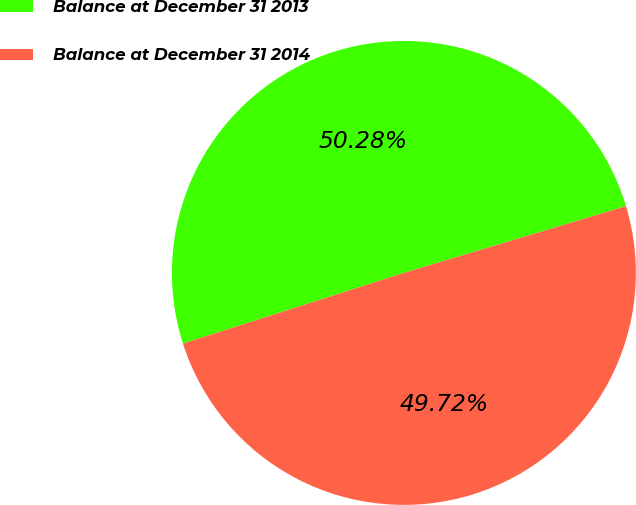Convert chart. <chart><loc_0><loc_0><loc_500><loc_500><pie_chart><fcel>Balance at December 31 2013<fcel>Balance at December 31 2014<nl><fcel>50.28%<fcel>49.72%<nl></chart> 